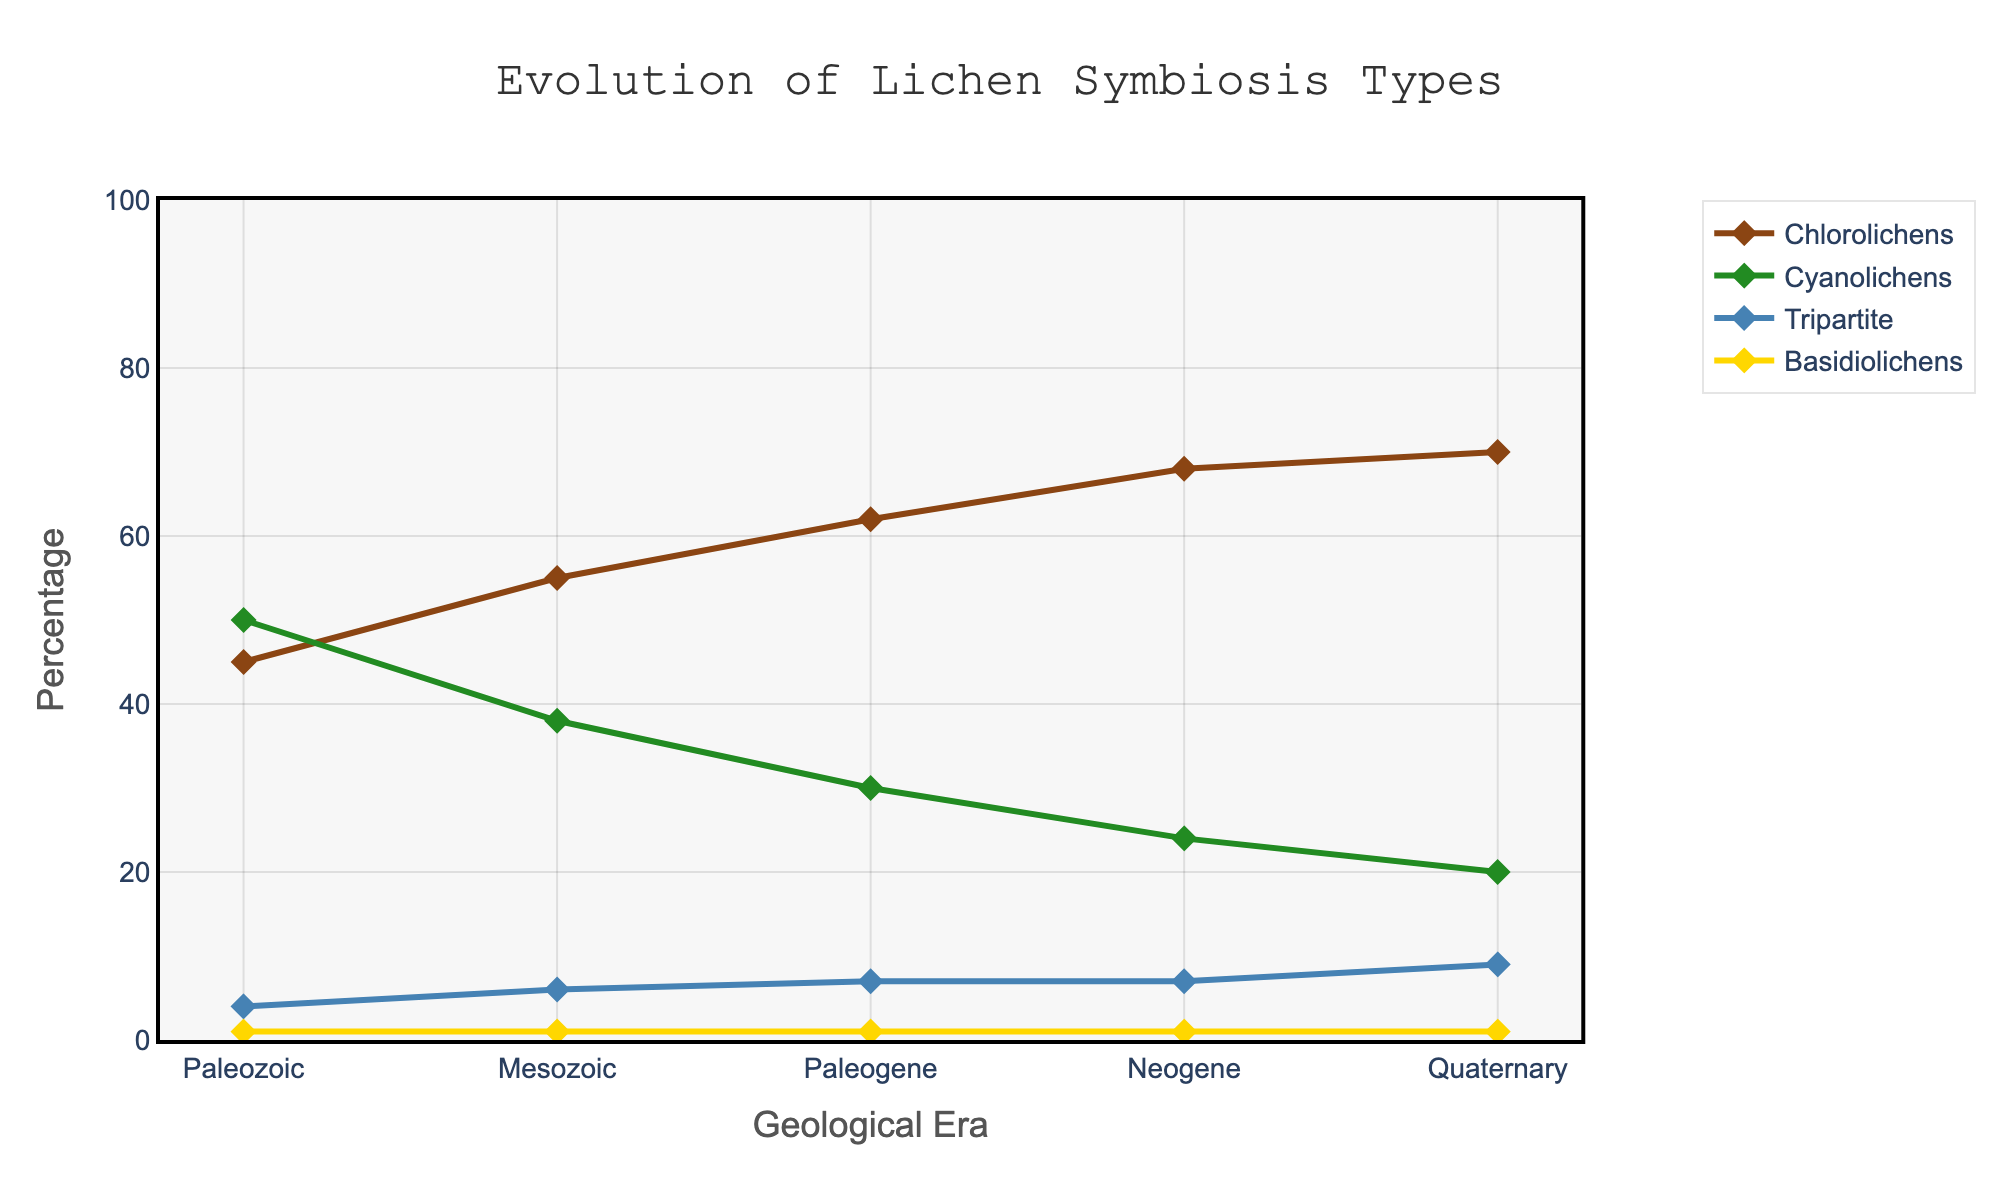What's the percentage increase in Chlorolichens from the Paleozoic to the Quaternary era? In the Paleozoic, the percentage of Chlorolichens is 45%. In the Quaternary, it is 70%. The percentage increase is calculated as ((70 - 45) / 45) * 100%.
Answer: 55.56% In which era did Cyanolichens have the highest percentage, and what was it? By examining the line for Cyanolichens, the highest percentage is observed in the Paleozoic era, which is 50%.
Answer: Paleozoic, 50% Which type of lichen had the smallest change in percentage over all the eras? Looking at the lines for each lichen type, Basidiolichens show the smallest change. The percentage remains constant at 1% throughout all geological eras.
Answer: Basidiolichens What is the sum of the percentages for Tripartite lichens from the Mesozoic through to the Quaternary eras? The percentages for Tripartite lichens are 6% (Mesozoic), 7% (Paleogene), 7% (Neogene), and 9% (Quaternary). Summing these up gives 6 + 7 + 7 + 9 = 29%.
Answer: 29% Between which two eras did Chlorolichens show the greatest increase in percentage? By considering the Chlorolichens line, the greatest increase is between the Paleogene (62%) and Neogene (68%). The increase is 68 - 62 = 6%.
Answer: Paleogene to Neogene At which era did the total percentage of Chlorolichens and Cyanolichens together reach its maximum, and what was it? Adding the percentages of Chlorolichens and Cyanolichens at each era, the maximum combined value is in the Paleozoic era with 45% (Chlorolichens) + 50% (Cyanolichens) = 95%.
Answer: Paleozoic, 95% What is the average percentage of Cyano-Tripartite-Basidiolichens (sum of percentages of Cyano lichens, Tripartite lichens, and Basidiolichens) across all eras? First, calculate the sum of Cyano lichens, Tripartite lichens, and Basidiolichens for each era, then divide by the number of eras. Paleozoic: 55%, Mesozoic: 45%, Paleogene: 38%, Neogene: 32%, Quaternary: 30%. The average is (55 + 45 + 38 + 32 + 30) / 5 = 200 / 5 = 40%.
Answer: 40% Which era shows the greatest difference in percentage between Chlorolichens and Cyanolichens? By computing the difference for each era: 
- Paleozoic: 50% - 45% = 5%
- Mesozoic: 55% - 38% = 17%
- Paleogene: 62% - 30% = 32%
- Neogene: 68% - 24% = 44%
- Quaternary: 70% - 20% = 50%
The greatest difference is in the Quaternary era with 50%.
Answer: Quaternary, 50% How many eras show a percentage increase in Tripartite lichens compared to the previous era? Tripartite lichens increase from Paleozoic (4%) to Mesozoic (6%), Mesozoic (6%) to Paleogene (7%), and Paleogene (7%) to Quaternary (9%). This happens 3 times: Paleozoic to Mesozoic, Mesozoic to Paleogene, and Paleogene to Quaternary.
Answer: 3 